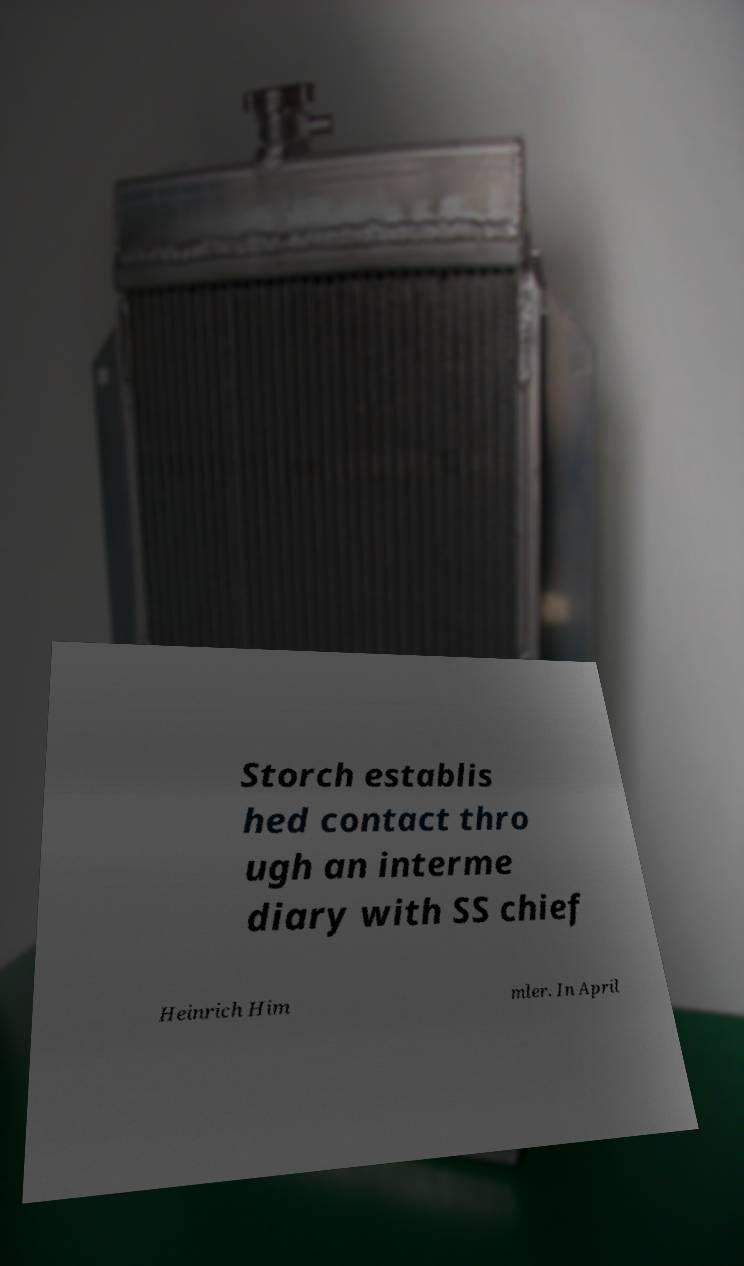Could you extract and type out the text from this image? Storch establis hed contact thro ugh an interme diary with SS chief Heinrich Him mler. In April 